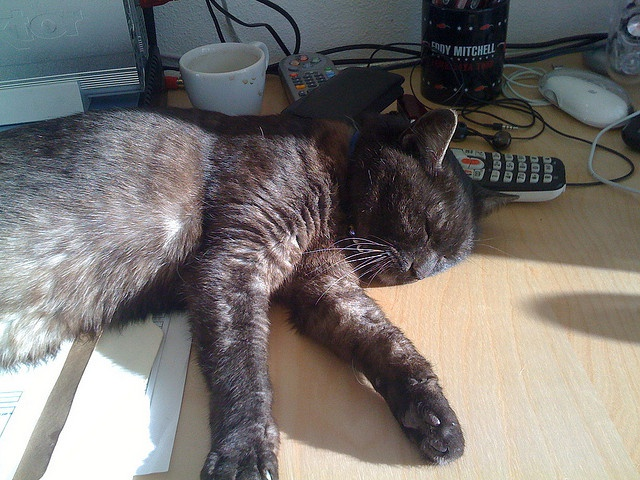Describe the objects in this image and their specific colors. I can see cat in gray, black, darkgray, and lightgray tones, tv in gray, black, and blue tones, cup in gray, black, and purple tones, cup in gray tones, and remote in gray, black, and maroon tones in this image. 